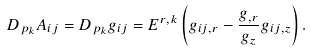<formula> <loc_0><loc_0><loc_500><loc_500>D _ { p _ { k } } A _ { i j } = D _ { p _ { k } } g _ { i j } = E ^ { r , k } \left ( g _ { i j , r } - \frac { g _ { , r } } { g _ { z } } g _ { i j , z } \right ) .</formula> 